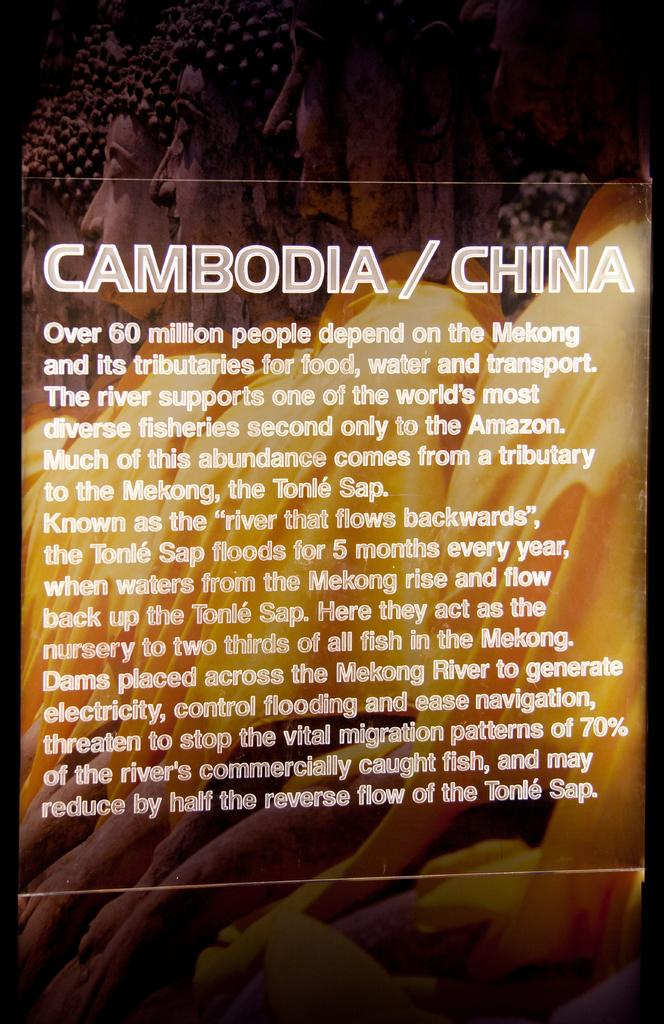What is the main subject of the image? The image contains the cover page of a book. Can you describe any specific details about the cover page? Unfortunately, the provided facts do not include any specific details about the cover page. How many crates are stacked on top of each other on the cover page? There is no mention of crates on the cover page, as the image only contains the cover page of a book. 